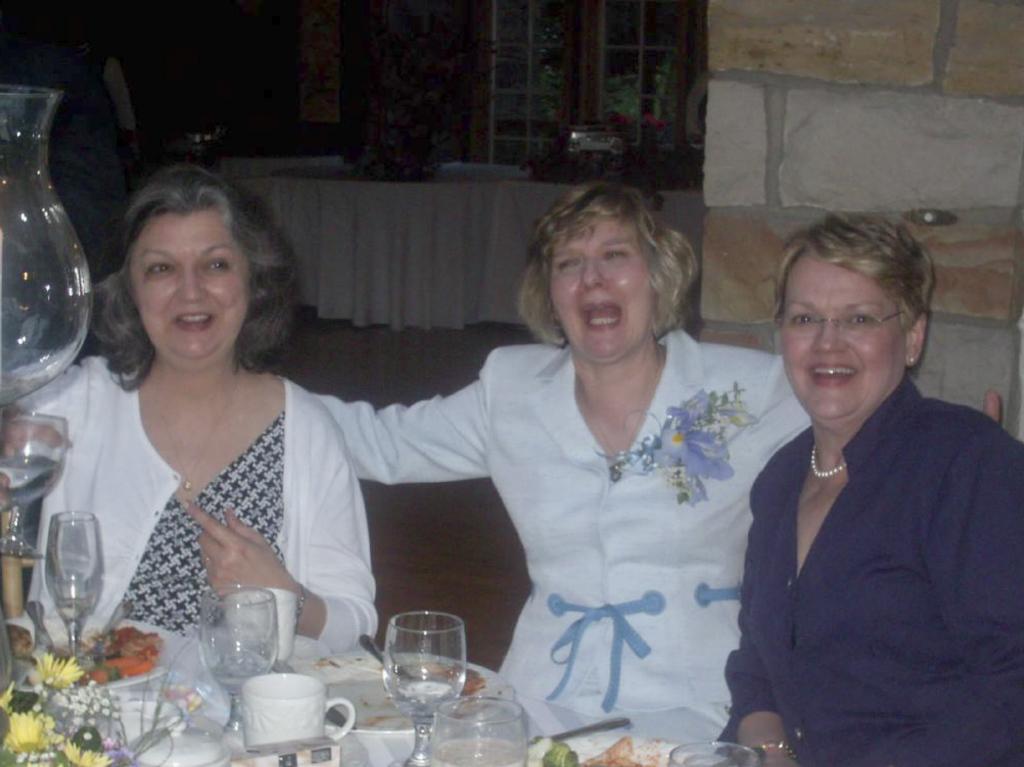How would you summarize this image in a sentence or two? In this image there are three persons sitting behind the table. There are glasses, plates, cups, spoons, flowers on the table. At the back there is a table which is covered with white color cloth, there is a window behind the table and at the right there is a pillar. 